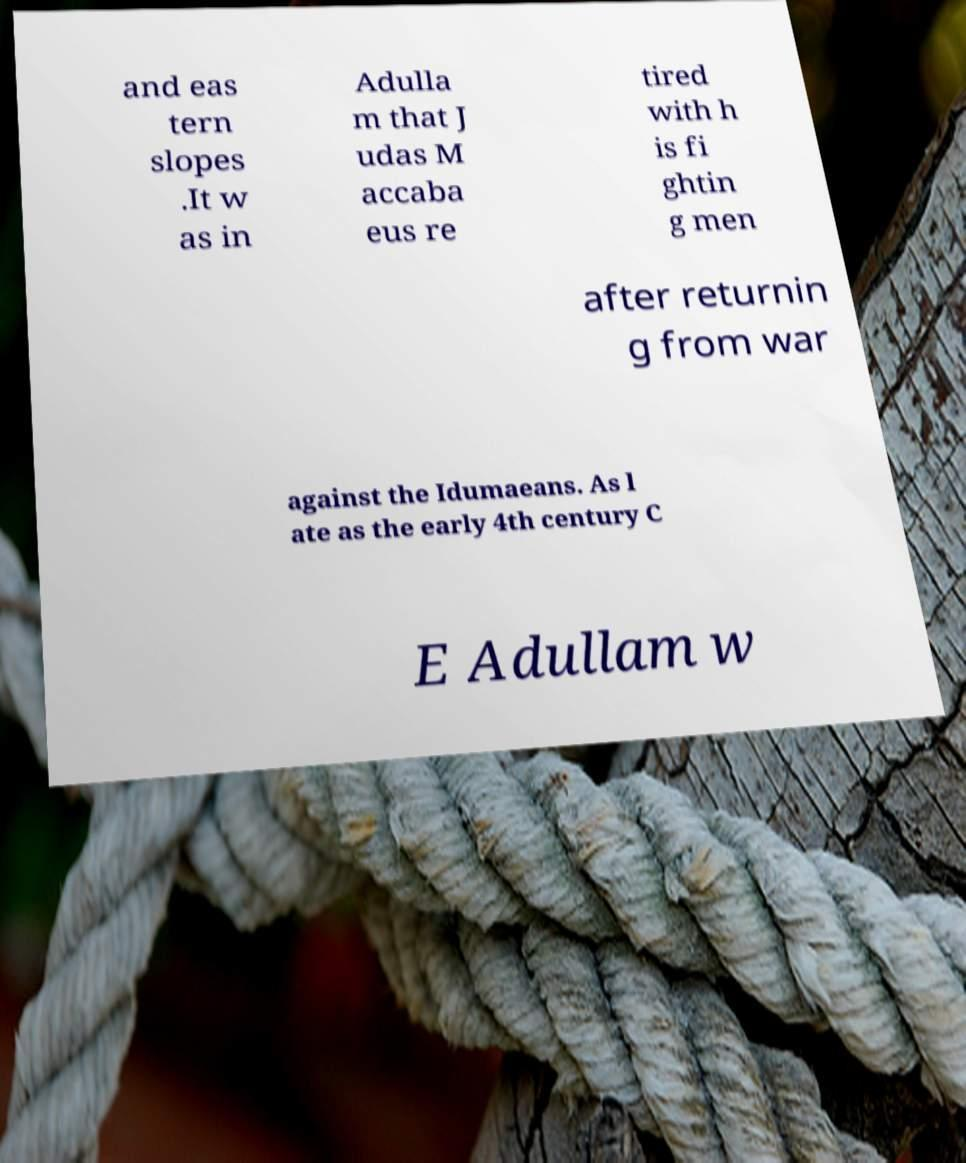For documentation purposes, I need the text within this image transcribed. Could you provide that? and eas tern slopes .It w as in Adulla m that J udas M accaba eus re tired with h is fi ghtin g men after returnin g from war against the Idumaeans. As l ate as the early 4th century C E Adullam w 